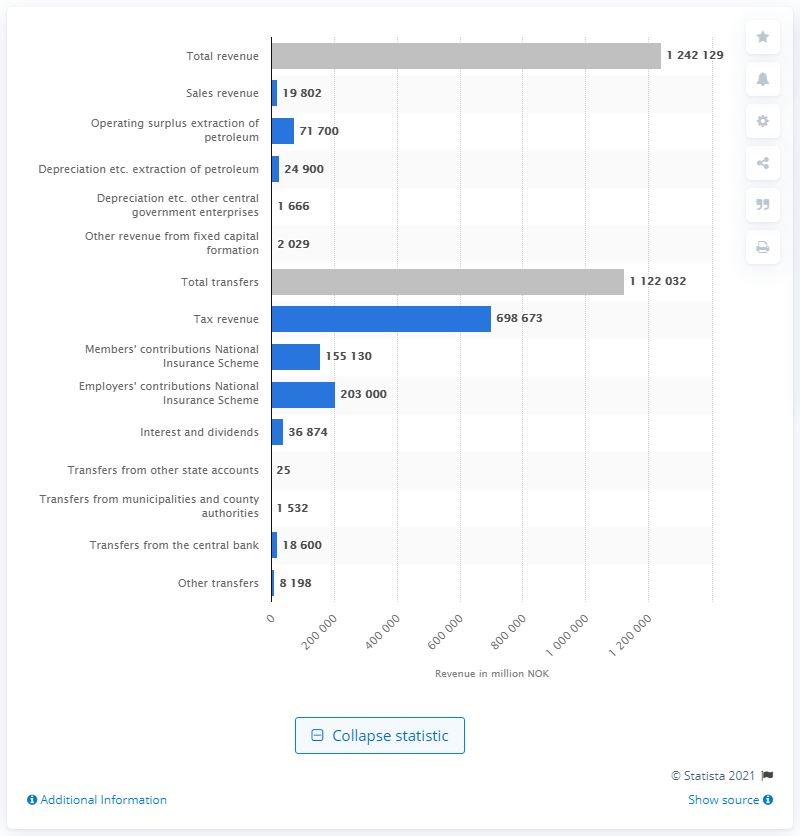List a handful of essential elements in this visual. The surplus extraction from the state petroleum operations in Norway was 71,700. 